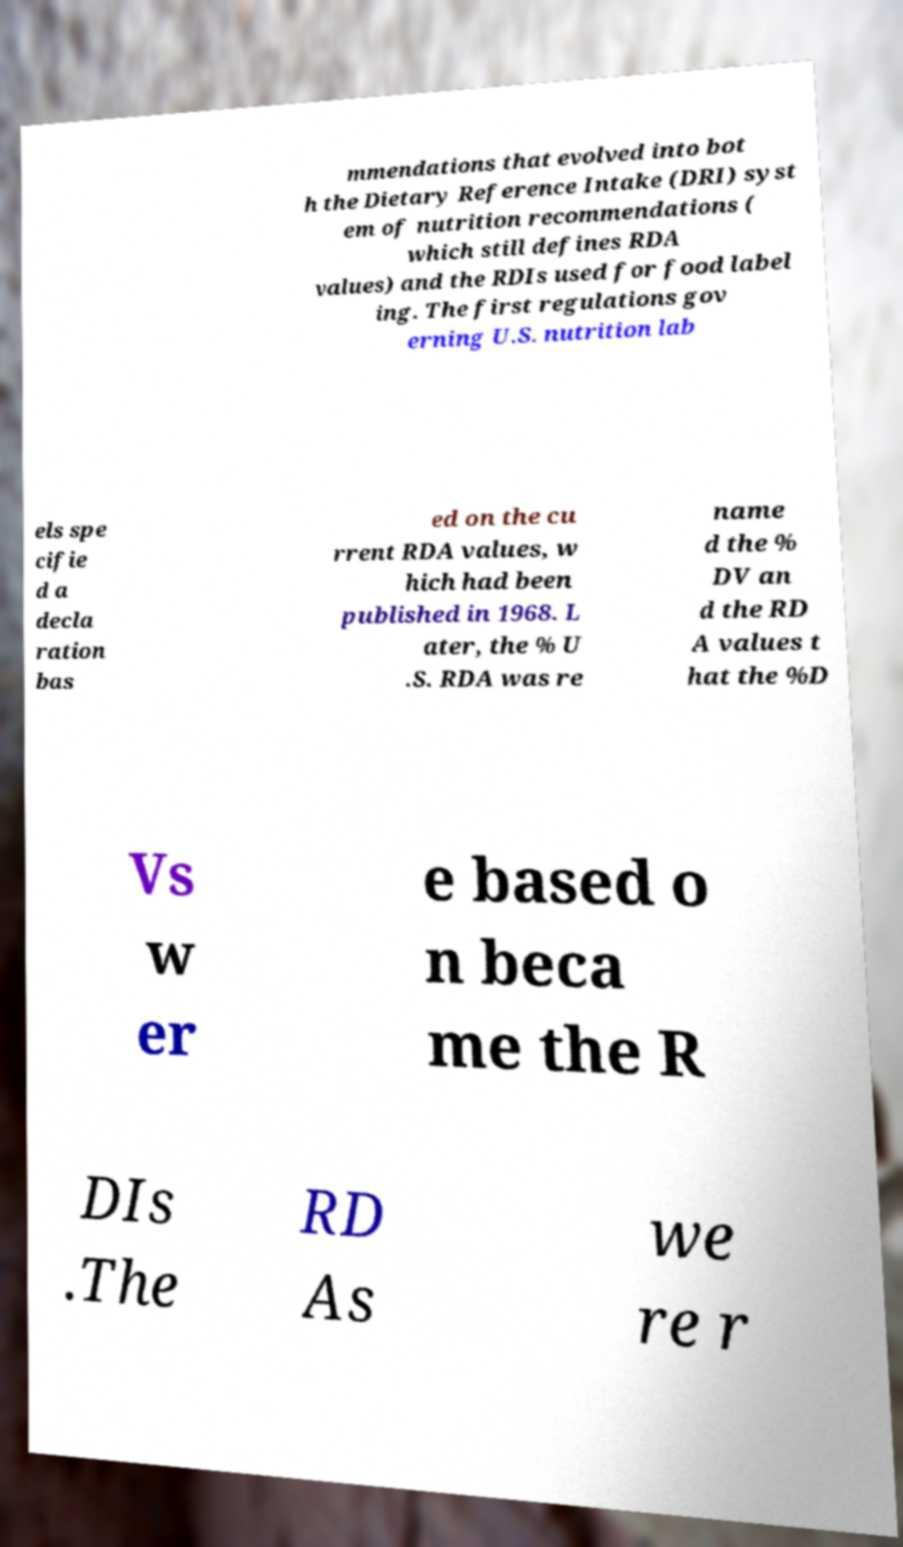I need the written content from this picture converted into text. Can you do that? mmendations that evolved into bot h the Dietary Reference Intake (DRI) syst em of nutrition recommendations ( which still defines RDA values) and the RDIs used for food label ing. The first regulations gov erning U.S. nutrition lab els spe cifie d a decla ration bas ed on the cu rrent RDA values, w hich had been published in 1968. L ater, the % U .S. RDA was re name d the % DV an d the RD A values t hat the %D Vs w er e based o n beca me the R DIs .The RD As we re r 